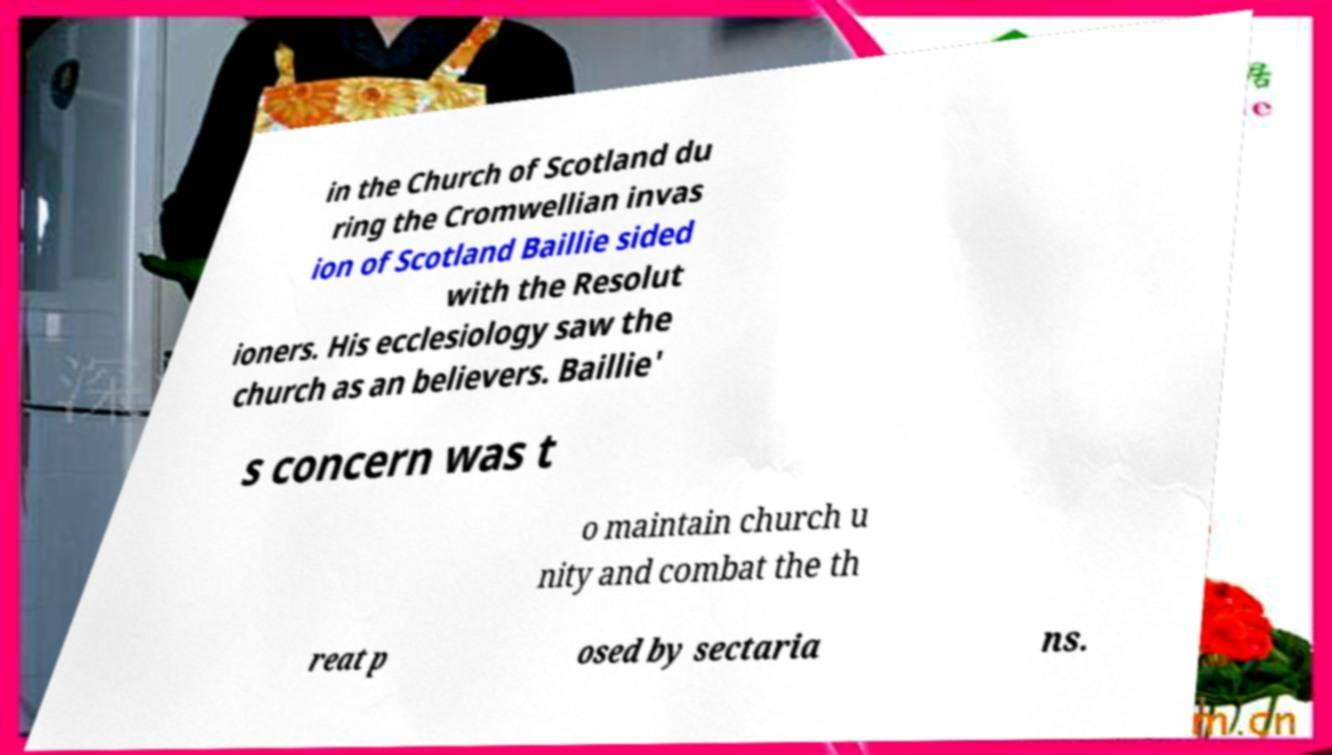There's text embedded in this image that I need extracted. Can you transcribe it verbatim? in the Church of Scotland du ring the Cromwellian invas ion of Scotland Baillie sided with the Resolut ioners. His ecclesiology saw the church as an believers. Baillie' s concern was t o maintain church u nity and combat the th reat p osed by sectaria ns. 